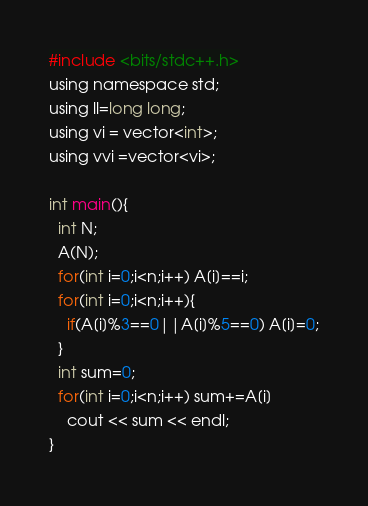Convert code to text. <code><loc_0><loc_0><loc_500><loc_500><_C_>#include <bits/stdc++.h>
using namespace std;
using ll=long long;
using vi = vector<int>;
using vvi =vector<vi>;

int main(){
  int N;
  A(N);
  for(int i=0;i<n;i++) A[i]==i;
  for(int i=0;i<n;i++){
    if(A[i]%3==0||A[i]%5==0) A[i]=0;
  }
  int sum=0;
  for(int i=0;i<n;i++) sum+=A[i]
    cout << sum << endl;
}</code> 